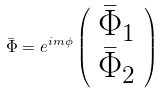<formula> <loc_0><loc_0><loc_500><loc_500>\bar { \Phi } = e ^ { i m \phi } \left ( \begin{array} { c } \bar { \Phi } _ { 1 } \\ \bar { \Phi } _ { 2 } \end{array} \right )</formula> 